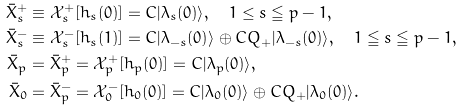<formula> <loc_0><loc_0><loc_500><loc_500>\bar { X } _ { s } ^ { + } & \equiv \mathcal { X } _ { s } ^ { + } [ h _ { s } ( 0 ) ] = C | \lambda _ { s } ( 0 ) \rangle , \quad 1 \leq s \leqq p - 1 , \\ \bar { X } _ { s } ^ { - } & \equiv \mathcal { X } _ { s } ^ { - } [ h _ { s } ( 1 ) ] = C | \lambda _ { - s } ( 0 ) \rangle \oplus C Q _ { + } | \lambda _ { - s } ( 0 ) \rangle , \quad 1 \leqq s \leqq p - 1 , \\ \bar { X } _ { p } & = \bar { X } _ { p } ^ { + } = \mathcal { X } _ { p } ^ { + } [ h _ { p } ( 0 ) ] = C | \lambda _ { p } ( 0 ) \rangle , \\ \bar { X } _ { 0 } & = \bar { X } _ { p } ^ { - } = \mathcal { X } _ { 0 } ^ { - } [ h _ { 0 } ( 0 ) ] = C | \lambda _ { 0 } ( 0 ) \rangle \oplus C Q _ { + } | \lambda _ { 0 } ( 0 ) \rangle .</formula> 